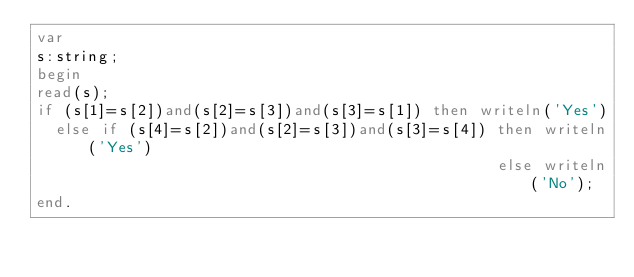<code> <loc_0><loc_0><loc_500><loc_500><_Pascal_>var
s:string;
begin
read(s);
if (s[1]=s[2])and(s[2]=s[3])and(s[3]=s[1]) then writeln('Yes')
  else if (s[4]=s[2])and(s[2]=s[3])and(s[3]=s[4]) then writeln('Yes')
                                                  else writeln('No');
end.</code> 